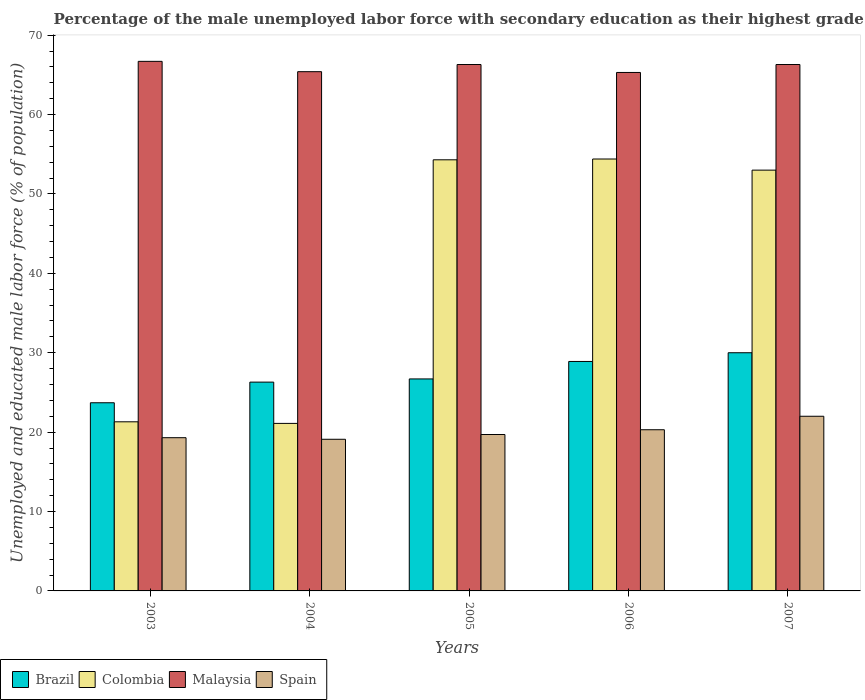How many different coloured bars are there?
Offer a terse response. 4. How many groups of bars are there?
Your answer should be very brief. 5. Are the number of bars on each tick of the X-axis equal?
Ensure brevity in your answer.  Yes. How many bars are there on the 2nd tick from the left?
Provide a succinct answer. 4. What is the percentage of the unemployed male labor force with secondary education in Colombia in 2003?
Provide a succinct answer. 21.3. Across all years, what is the maximum percentage of the unemployed male labor force with secondary education in Malaysia?
Your response must be concise. 66.7. Across all years, what is the minimum percentage of the unemployed male labor force with secondary education in Brazil?
Offer a very short reply. 23.7. In which year was the percentage of the unemployed male labor force with secondary education in Spain maximum?
Make the answer very short. 2007. What is the total percentage of the unemployed male labor force with secondary education in Spain in the graph?
Provide a succinct answer. 100.4. What is the difference between the percentage of the unemployed male labor force with secondary education in Malaysia in 2004 and that in 2005?
Your answer should be very brief. -0.9. What is the difference between the percentage of the unemployed male labor force with secondary education in Spain in 2007 and the percentage of the unemployed male labor force with secondary education in Brazil in 2006?
Give a very brief answer. -6.9. What is the average percentage of the unemployed male labor force with secondary education in Malaysia per year?
Provide a succinct answer. 66. In the year 2007, what is the difference between the percentage of the unemployed male labor force with secondary education in Spain and percentage of the unemployed male labor force with secondary education in Colombia?
Ensure brevity in your answer.  -31. What is the ratio of the percentage of the unemployed male labor force with secondary education in Brazil in 2004 to that in 2006?
Provide a succinct answer. 0.91. Is the percentage of the unemployed male labor force with secondary education in Spain in 2003 less than that in 2006?
Keep it short and to the point. Yes. Is the difference between the percentage of the unemployed male labor force with secondary education in Spain in 2003 and 2006 greater than the difference between the percentage of the unemployed male labor force with secondary education in Colombia in 2003 and 2006?
Provide a succinct answer. Yes. What is the difference between the highest and the second highest percentage of the unemployed male labor force with secondary education in Colombia?
Your response must be concise. 0.1. What is the difference between the highest and the lowest percentage of the unemployed male labor force with secondary education in Spain?
Make the answer very short. 2.9. What does the 1st bar from the right in 2006 represents?
Offer a terse response. Spain. Are all the bars in the graph horizontal?
Your answer should be very brief. No. What is the difference between two consecutive major ticks on the Y-axis?
Give a very brief answer. 10. Does the graph contain grids?
Give a very brief answer. No. How are the legend labels stacked?
Give a very brief answer. Horizontal. What is the title of the graph?
Make the answer very short. Percentage of the male unemployed labor force with secondary education as their highest grade. Does "St. Vincent and the Grenadines" appear as one of the legend labels in the graph?
Offer a very short reply. No. What is the label or title of the Y-axis?
Ensure brevity in your answer.  Unemployed and educated male labor force (% of population). What is the Unemployed and educated male labor force (% of population) of Brazil in 2003?
Keep it short and to the point. 23.7. What is the Unemployed and educated male labor force (% of population) of Colombia in 2003?
Provide a succinct answer. 21.3. What is the Unemployed and educated male labor force (% of population) in Malaysia in 2003?
Your response must be concise. 66.7. What is the Unemployed and educated male labor force (% of population) of Spain in 2003?
Ensure brevity in your answer.  19.3. What is the Unemployed and educated male labor force (% of population) in Brazil in 2004?
Give a very brief answer. 26.3. What is the Unemployed and educated male labor force (% of population) of Colombia in 2004?
Your response must be concise. 21.1. What is the Unemployed and educated male labor force (% of population) of Malaysia in 2004?
Offer a terse response. 65.4. What is the Unemployed and educated male labor force (% of population) in Spain in 2004?
Keep it short and to the point. 19.1. What is the Unemployed and educated male labor force (% of population) of Brazil in 2005?
Your answer should be compact. 26.7. What is the Unemployed and educated male labor force (% of population) in Colombia in 2005?
Give a very brief answer. 54.3. What is the Unemployed and educated male labor force (% of population) of Malaysia in 2005?
Your answer should be very brief. 66.3. What is the Unemployed and educated male labor force (% of population) of Spain in 2005?
Offer a very short reply. 19.7. What is the Unemployed and educated male labor force (% of population) in Brazil in 2006?
Your response must be concise. 28.9. What is the Unemployed and educated male labor force (% of population) in Colombia in 2006?
Your answer should be compact. 54.4. What is the Unemployed and educated male labor force (% of population) of Malaysia in 2006?
Make the answer very short. 65.3. What is the Unemployed and educated male labor force (% of population) of Spain in 2006?
Provide a short and direct response. 20.3. What is the Unemployed and educated male labor force (% of population) in Brazil in 2007?
Make the answer very short. 30. What is the Unemployed and educated male labor force (% of population) of Malaysia in 2007?
Make the answer very short. 66.3. Across all years, what is the maximum Unemployed and educated male labor force (% of population) in Colombia?
Your answer should be very brief. 54.4. Across all years, what is the maximum Unemployed and educated male labor force (% of population) of Malaysia?
Your response must be concise. 66.7. Across all years, what is the minimum Unemployed and educated male labor force (% of population) of Brazil?
Provide a succinct answer. 23.7. Across all years, what is the minimum Unemployed and educated male labor force (% of population) in Colombia?
Make the answer very short. 21.1. Across all years, what is the minimum Unemployed and educated male labor force (% of population) in Malaysia?
Your response must be concise. 65.3. Across all years, what is the minimum Unemployed and educated male labor force (% of population) in Spain?
Your answer should be very brief. 19.1. What is the total Unemployed and educated male labor force (% of population) in Brazil in the graph?
Your answer should be compact. 135.6. What is the total Unemployed and educated male labor force (% of population) of Colombia in the graph?
Offer a very short reply. 204.1. What is the total Unemployed and educated male labor force (% of population) of Malaysia in the graph?
Keep it short and to the point. 330. What is the total Unemployed and educated male labor force (% of population) of Spain in the graph?
Your answer should be very brief. 100.4. What is the difference between the Unemployed and educated male labor force (% of population) of Colombia in 2003 and that in 2004?
Your answer should be compact. 0.2. What is the difference between the Unemployed and educated male labor force (% of population) of Malaysia in 2003 and that in 2004?
Your answer should be compact. 1.3. What is the difference between the Unemployed and educated male labor force (% of population) in Colombia in 2003 and that in 2005?
Make the answer very short. -33. What is the difference between the Unemployed and educated male labor force (% of population) in Brazil in 2003 and that in 2006?
Your answer should be very brief. -5.2. What is the difference between the Unemployed and educated male labor force (% of population) in Colombia in 2003 and that in 2006?
Keep it short and to the point. -33.1. What is the difference between the Unemployed and educated male labor force (% of population) in Malaysia in 2003 and that in 2006?
Your answer should be very brief. 1.4. What is the difference between the Unemployed and educated male labor force (% of population) of Brazil in 2003 and that in 2007?
Ensure brevity in your answer.  -6.3. What is the difference between the Unemployed and educated male labor force (% of population) in Colombia in 2003 and that in 2007?
Provide a succinct answer. -31.7. What is the difference between the Unemployed and educated male labor force (% of population) of Malaysia in 2003 and that in 2007?
Your answer should be very brief. 0.4. What is the difference between the Unemployed and educated male labor force (% of population) of Brazil in 2004 and that in 2005?
Your answer should be very brief. -0.4. What is the difference between the Unemployed and educated male labor force (% of population) in Colombia in 2004 and that in 2005?
Your answer should be compact. -33.2. What is the difference between the Unemployed and educated male labor force (% of population) in Malaysia in 2004 and that in 2005?
Keep it short and to the point. -0.9. What is the difference between the Unemployed and educated male labor force (% of population) of Spain in 2004 and that in 2005?
Provide a short and direct response. -0.6. What is the difference between the Unemployed and educated male labor force (% of population) in Brazil in 2004 and that in 2006?
Your response must be concise. -2.6. What is the difference between the Unemployed and educated male labor force (% of population) of Colombia in 2004 and that in 2006?
Provide a succinct answer. -33.3. What is the difference between the Unemployed and educated male labor force (% of population) in Colombia in 2004 and that in 2007?
Your answer should be compact. -31.9. What is the difference between the Unemployed and educated male labor force (% of population) of Spain in 2004 and that in 2007?
Provide a short and direct response. -2.9. What is the difference between the Unemployed and educated male labor force (% of population) of Brazil in 2005 and that in 2006?
Your answer should be compact. -2.2. What is the difference between the Unemployed and educated male labor force (% of population) of Colombia in 2005 and that in 2006?
Give a very brief answer. -0.1. What is the difference between the Unemployed and educated male labor force (% of population) of Spain in 2005 and that in 2006?
Your answer should be compact. -0.6. What is the difference between the Unemployed and educated male labor force (% of population) of Spain in 2005 and that in 2007?
Keep it short and to the point. -2.3. What is the difference between the Unemployed and educated male labor force (% of population) in Colombia in 2006 and that in 2007?
Your response must be concise. 1.4. What is the difference between the Unemployed and educated male labor force (% of population) of Malaysia in 2006 and that in 2007?
Offer a terse response. -1. What is the difference between the Unemployed and educated male labor force (% of population) of Spain in 2006 and that in 2007?
Your answer should be compact. -1.7. What is the difference between the Unemployed and educated male labor force (% of population) in Brazil in 2003 and the Unemployed and educated male labor force (% of population) in Malaysia in 2004?
Provide a short and direct response. -41.7. What is the difference between the Unemployed and educated male labor force (% of population) in Colombia in 2003 and the Unemployed and educated male labor force (% of population) in Malaysia in 2004?
Your answer should be compact. -44.1. What is the difference between the Unemployed and educated male labor force (% of population) in Malaysia in 2003 and the Unemployed and educated male labor force (% of population) in Spain in 2004?
Keep it short and to the point. 47.6. What is the difference between the Unemployed and educated male labor force (% of population) of Brazil in 2003 and the Unemployed and educated male labor force (% of population) of Colombia in 2005?
Your response must be concise. -30.6. What is the difference between the Unemployed and educated male labor force (% of population) in Brazil in 2003 and the Unemployed and educated male labor force (% of population) in Malaysia in 2005?
Your response must be concise. -42.6. What is the difference between the Unemployed and educated male labor force (% of population) in Colombia in 2003 and the Unemployed and educated male labor force (% of population) in Malaysia in 2005?
Offer a very short reply. -45. What is the difference between the Unemployed and educated male labor force (% of population) of Colombia in 2003 and the Unemployed and educated male labor force (% of population) of Spain in 2005?
Your answer should be very brief. 1.6. What is the difference between the Unemployed and educated male labor force (% of population) of Malaysia in 2003 and the Unemployed and educated male labor force (% of population) of Spain in 2005?
Offer a terse response. 47. What is the difference between the Unemployed and educated male labor force (% of population) in Brazil in 2003 and the Unemployed and educated male labor force (% of population) in Colombia in 2006?
Make the answer very short. -30.7. What is the difference between the Unemployed and educated male labor force (% of population) in Brazil in 2003 and the Unemployed and educated male labor force (% of population) in Malaysia in 2006?
Offer a terse response. -41.6. What is the difference between the Unemployed and educated male labor force (% of population) of Brazil in 2003 and the Unemployed and educated male labor force (% of population) of Spain in 2006?
Provide a succinct answer. 3.4. What is the difference between the Unemployed and educated male labor force (% of population) in Colombia in 2003 and the Unemployed and educated male labor force (% of population) in Malaysia in 2006?
Offer a very short reply. -44. What is the difference between the Unemployed and educated male labor force (% of population) of Malaysia in 2003 and the Unemployed and educated male labor force (% of population) of Spain in 2006?
Ensure brevity in your answer.  46.4. What is the difference between the Unemployed and educated male labor force (% of population) in Brazil in 2003 and the Unemployed and educated male labor force (% of population) in Colombia in 2007?
Give a very brief answer. -29.3. What is the difference between the Unemployed and educated male labor force (% of population) of Brazil in 2003 and the Unemployed and educated male labor force (% of population) of Malaysia in 2007?
Give a very brief answer. -42.6. What is the difference between the Unemployed and educated male labor force (% of population) of Brazil in 2003 and the Unemployed and educated male labor force (% of population) of Spain in 2007?
Offer a terse response. 1.7. What is the difference between the Unemployed and educated male labor force (% of population) in Colombia in 2003 and the Unemployed and educated male labor force (% of population) in Malaysia in 2007?
Give a very brief answer. -45. What is the difference between the Unemployed and educated male labor force (% of population) of Colombia in 2003 and the Unemployed and educated male labor force (% of population) of Spain in 2007?
Your answer should be compact. -0.7. What is the difference between the Unemployed and educated male labor force (% of population) in Malaysia in 2003 and the Unemployed and educated male labor force (% of population) in Spain in 2007?
Your response must be concise. 44.7. What is the difference between the Unemployed and educated male labor force (% of population) in Brazil in 2004 and the Unemployed and educated male labor force (% of population) in Colombia in 2005?
Make the answer very short. -28. What is the difference between the Unemployed and educated male labor force (% of population) of Brazil in 2004 and the Unemployed and educated male labor force (% of population) of Malaysia in 2005?
Provide a short and direct response. -40. What is the difference between the Unemployed and educated male labor force (% of population) of Colombia in 2004 and the Unemployed and educated male labor force (% of population) of Malaysia in 2005?
Offer a terse response. -45.2. What is the difference between the Unemployed and educated male labor force (% of population) of Malaysia in 2004 and the Unemployed and educated male labor force (% of population) of Spain in 2005?
Provide a succinct answer. 45.7. What is the difference between the Unemployed and educated male labor force (% of population) of Brazil in 2004 and the Unemployed and educated male labor force (% of population) of Colombia in 2006?
Your answer should be compact. -28.1. What is the difference between the Unemployed and educated male labor force (% of population) in Brazil in 2004 and the Unemployed and educated male labor force (% of population) in Malaysia in 2006?
Offer a terse response. -39. What is the difference between the Unemployed and educated male labor force (% of population) in Brazil in 2004 and the Unemployed and educated male labor force (% of population) in Spain in 2006?
Provide a succinct answer. 6. What is the difference between the Unemployed and educated male labor force (% of population) in Colombia in 2004 and the Unemployed and educated male labor force (% of population) in Malaysia in 2006?
Offer a very short reply. -44.2. What is the difference between the Unemployed and educated male labor force (% of population) of Colombia in 2004 and the Unemployed and educated male labor force (% of population) of Spain in 2006?
Provide a succinct answer. 0.8. What is the difference between the Unemployed and educated male labor force (% of population) of Malaysia in 2004 and the Unemployed and educated male labor force (% of population) of Spain in 2006?
Make the answer very short. 45.1. What is the difference between the Unemployed and educated male labor force (% of population) of Brazil in 2004 and the Unemployed and educated male labor force (% of population) of Colombia in 2007?
Keep it short and to the point. -26.7. What is the difference between the Unemployed and educated male labor force (% of population) of Brazil in 2004 and the Unemployed and educated male labor force (% of population) of Malaysia in 2007?
Your answer should be very brief. -40. What is the difference between the Unemployed and educated male labor force (% of population) of Colombia in 2004 and the Unemployed and educated male labor force (% of population) of Malaysia in 2007?
Make the answer very short. -45.2. What is the difference between the Unemployed and educated male labor force (% of population) of Colombia in 2004 and the Unemployed and educated male labor force (% of population) of Spain in 2007?
Provide a short and direct response. -0.9. What is the difference between the Unemployed and educated male labor force (% of population) in Malaysia in 2004 and the Unemployed and educated male labor force (% of population) in Spain in 2007?
Keep it short and to the point. 43.4. What is the difference between the Unemployed and educated male labor force (% of population) in Brazil in 2005 and the Unemployed and educated male labor force (% of population) in Colombia in 2006?
Make the answer very short. -27.7. What is the difference between the Unemployed and educated male labor force (% of population) in Brazil in 2005 and the Unemployed and educated male labor force (% of population) in Malaysia in 2006?
Offer a terse response. -38.6. What is the difference between the Unemployed and educated male labor force (% of population) of Colombia in 2005 and the Unemployed and educated male labor force (% of population) of Malaysia in 2006?
Give a very brief answer. -11. What is the difference between the Unemployed and educated male labor force (% of population) in Colombia in 2005 and the Unemployed and educated male labor force (% of population) in Spain in 2006?
Make the answer very short. 34. What is the difference between the Unemployed and educated male labor force (% of population) of Brazil in 2005 and the Unemployed and educated male labor force (% of population) of Colombia in 2007?
Your answer should be compact. -26.3. What is the difference between the Unemployed and educated male labor force (% of population) of Brazil in 2005 and the Unemployed and educated male labor force (% of population) of Malaysia in 2007?
Your answer should be compact. -39.6. What is the difference between the Unemployed and educated male labor force (% of population) in Brazil in 2005 and the Unemployed and educated male labor force (% of population) in Spain in 2007?
Ensure brevity in your answer.  4.7. What is the difference between the Unemployed and educated male labor force (% of population) in Colombia in 2005 and the Unemployed and educated male labor force (% of population) in Malaysia in 2007?
Give a very brief answer. -12. What is the difference between the Unemployed and educated male labor force (% of population) in Colombia in 2005 and the Unemployed and educated male labor force (% of population) in Spain in 2007?
Give a very brief answer. 32.3. What is the difference between the Unemployed and educated male labor force (% of population) in Malaysia in 2005 and the Unemployed and educated male labor force (% of population) in Spain in 2007?
Your answer should be very brief. 44.3. What is the difference between the Unemployed and educated male labor force (% of population) in Brazil in 2006 and the Unemployed and educated male labor force (% of population) in Colombia in 2007?
Your answer should be compact. -24.1. What is the difference between the Unemployed and educated male labor force (% of population) in Brazil in 2006 and the Unemployed and educated male labor force (% of population) in Malaysia in 2007?
Provide a short and direct response. -37.4. What is the difference between the Unemployed and educated male labor force (% of population) in Colombia in 2006 and the Unemployed and educated male labor force (% of population) in Spain in 2007?
Ensure brevity in your answer.  32.4. What is the difference between the Unemployed and educated male labor force (% of population) of Malaysia in 2006 and the Unemployed and educated male labor force (% of population) of Spain in 2007?
Provide a short and direct response. 43.3. What is the average Unemployed and educated male labor force (% of population) in Brazil per year?
Offer a very short reply. 27.12. What is the average Unemployed and educated male labor force (% of population) of Colombia per year?
Give a very brief answer. 40.82. What is the average Unemployed and educated male labor force (% of population) of Malaysia per year?
Your answer should be compact. 66. What is the average Unemployed and educated male labor force (% of population) of Spain per year?
Provide a short and direct response. 20.08. In the year 2003, what is the difference between the Unemployed and educated male labor force (% of population) of Brazil and Unemployed and educated male labor force (% of population) of Malaysia?
Ensure brevity in your answer.  -43. In the year 2003, what is the difference between the Unemployed and educated male labor force (% of population) in Brazil and Unemployed and educated male labor force (% of population) in Spain?
Your answer should be very brief. 4.4. In the year 2003, what is the difference between the Unemployed and educated male labor force (% of population) in Colombia and Unemployed and educated male labor force (% of population) in Malaysia?
Your answer should be very brief. -45.4. In the year 2003, what is the difference between the Unemployed and educated male labor force (% of population) in Malaysia and Unemployed and educated male labor force (% of population) in Spain?
Ensure brevity in your answer.  47.4. In the year 2004, what is the difference between the Unemployed and educated male labor force (% of population) in Brazil and Unemployed and educated male labor force (% of population) in Malaysia?
Give a very brief answer. -39.1. In the year 2004, what is the difference between the Unemployed and educated male labor force (% of population) in Brazil and Unemployed and educated male labor force (% of population) in Spain?
Offer a very short reply. 7.2. In the year 2004, what is the difference between the Unemployed and educated male labor force (% of population) in Colombia and Unemployed and educated male labor force (% of population) in Malaysia?
Your response must be concise. -44.3. In the year 2004, what is the difference between the Unemployed and educated male labor force (% of population) in Malaysia and Unemployed and educated male labor force (% of population) in Spain?
Provide a succinct answer. 46.3. In the year 2005, what is the difference between the Unemployed and educated male labor force (% of population) of Brazil and Unemployed and educated male labor force (% of population) of Colombia?
Provide a succinct answer. -27.6. In the year 2005, what is the difference between the Unemployed and educated male labor force (% of population) in Brazil and Unemployed and educated male labor force (% of population) in Malaysia?
Your response must be concise. -39.6. In the year 2005, what is the difference between the Unemployed and educated male labor force (% of population) in Colombia and Unemployed and educated male labor force (% of population) in Spain?
Your response must be concise. 34.6. In the year 2005, what is the difference between the Unemployed and educated male labor force (% of population) in Malaysia and Unemployed and educated male labor force (% of population) in Spain?
Keep it short and to the point. 46.6. In the year 2006, what is the difference between the Unemployed and educated male labor force (% of population) in Brazil and Unemployed and educated male labor force (% of population) in Colombia?
Keep it short and to the point. -25.5. In the year 2006, what is the difference between the Unemployed and educated male labor force (% of population) of Brazil and Unemployed and educated male labor force (% of population) of Malaysia?
Your response must be concise. -36.4. In the year 2006, what is the difference between the Unemployed and educated male labor force (% of population) in Brazil and Unemployed and educated male labor force (% of population) in Spain?
Your answer should be very brief. 8.6. In the year 2006, what is the difference between the Unemployed and educated male labor force (% of population) of Colombia and Unemployed and educated male labor force (% of population) of Spain?
Keep it short and to the point. 34.1. In the year 2006, what is the difference between the Unemployed and educated male labor force (% of population) in Malaysia and Unemployed and educated male labor force (% of population) in Spain?
Offer a terse response. 45. In the year 2007, what is the difference between the Unemployed and educated male labor force (% of population) of Brazil and Unemployed and educated male labor force (% of population) of Malaysia?
Provide a short and direct response. -36.3. In the year 2007, what is the difference between the Unemployed and educated male labor force (% of population) in Brazil and Unemployed and educated male labor force (% of population) in Spain?
Ensure brevity in your answer.  8. In the year 2007, what is the difference between the Unemployed and educated male labor force (% of population) in Malaysia and Unemployed and educated male labor force (% of population) in Spain?
Keep it short and to the point. 44.3. What is the ratio of the Unemployed and educated male labor force (% of population) of Brazil in 2003 to that in 2004?
Give a very brief answer. 0.9. What is the ratio of the Unemployed and educated male labor force (% of population) in Colombia in 2003 to that in 2004?
Give a very brief answer. 1.01. What is the ratio of the Unemployed and educated male labor force (% of population) in Malaysia in 2003 to that in 2004?
Your response must be concise. 1.02. What is the ratio of the Unemployed and educated male labor force (% of population) of Spain in 2003 to that in 2004?
Offer a very short reply. 1.01. What is the ratio of the Unemployed and educated male labor force (% of population) of Brazil in 2003 to that in 2005?
Offer a very short reply. 0.89. What is the ratio of the Unemployed and educated male labor force (% of population) in Colombia in 2003 to that in 2005?
Provide a succinct answer. 0.39. What is the ratio of the Unemployed and educated male labor force (% of population) of Spain in 2003 to that in 2005?
Your answer should be very brief. 0.98. What is the ratio of the Unemployed and educated male labor force (% of population) of Brazil in 2003 to that in 2006?
Your answer should be compact. 0.82. What is the ratio of the Unemployed and educated male labor force (% of population) in Colombia in 2003 to that in 2006?
Offer a very short reply. 0.39. What is the ratio of the Unemployed and educated male labor force (% of population) of Malaysia in 2003 to that in 2006?
Keep it short and to the point. 1.02. What is the ratio of the Unemployed and educated male labor force (% of population) of Spain in 2003 to that in 2006?
Give a very brief answer. 0.95. What is the ratio of the Unemployed and educated male labor force (% of population) of Brazil in 2003 to that in 2007?
Offer a very short reply. 0.79. What is the ratio of the Unemployed and educated male labor force (% of population) of Colombia in 2003 to that in 2007?
Your answer should be very brief. 0.4. What is the ratio of the Unemployed and educated male labor force (% of population) in Spain in 2003 to that in 2007?
Provide a short and direct response. 0.88. What is the ratio of the Unemployed and educated male labor force (% of population) of Colombia in 2004 to that in 2005?
Keep it short and to the point. 0.39. What is the ratio of the Unemployed and educated male labor force (% of population) in Malaysia in 2004 to that in 2005?
Your answer should be very brief. 0.99. What is the ratio of the Unemployed and educated male labor force (% of population) of Spain in 2004 to that in 2005?
Provide a short and direct response. 0.97. What is the ratio of the Unemployed and educated male labor force (% of population) of Brazil in 2004 to that in 2006?
Ensure brevity in your answer.  0.91. What is the ratio of the Unemployed and educated male labor force (% of population) in Colombia in 2004 to that in 2006?
Offer a very short reply. 0.39. What is the ratio of the Unemployed and educated male labor force (% of population) in Spain in 2004 to that in 2006?
Your answer should be compact. 0.94. What is the ratio of the Unemployed and educated male labor force (% of population) of Brazil in 2004 to that in 2007?
Offer a terse response. 0.88. What is the ratio of the Unemployed and educated male labor force (% of population) of Colombia in 2004 to that in 2007?
Your response must be concise. 0.4. What is the ratio of the Unemployed and educated male labor force (% of population) in Malaysia in 2004 to that in 2007?
Make the answer very short. 0.99. What is the ratio of the Unemployed and educated male labor force (% of population) of Spain in 2004 to that in 2007?
Keep it short and to the point. 0.87. What is the ratio of the Unemployed and educated male labor force (% of population) of Brazil in 2005 to that in 2006?
Your answer should be very brief. 0.92. What is the ratio of the Unemployed and educated male labor force (% of population) of Malaysia in 2005 to that in 2006?
Give a very brief answer. 1.02. What is the ratio of the Unemployed and educated male labor force (% of population) of Spain in 2005 to that in 2006?
Your answer should be very brief. 0.97. What is the ratio of the Unemployed and educated male labor force (% of population) in Brazil in 2005 to that in 2007?
Give a very brief answer. 0.89. What is the ratio of the Unemployed and educated male labor force (% of population) of Colombia in 2005 to that in 2007?
Give a very brief answer. 1.02. What is the ratio of the Unemployed and educated male labor force (% of population) in Malaysia in 2005 to that in 2007?
Give a very brief answer. 1. What is the ratio of the Unemployed and educated male labor force (% of population) in Spain in 2005 to that in 2007?
Offer a very short reply. 0.9. What is the ratio of the Unemployed and educated male labor force (% of population) of Brazil in 2006 to that in 2007?
Offer a terse response. 0.96. What is the ratio of the Unemployed and educated male labor force (% of population) of Colombia in 2006 to that in 2007?
Make the answer very short. 1.03. What is the ratio of the Unemployed and educated male labor force (% of population) of Malaysia in 2006 to that in 2007?
Offer a very short reply. 0.98. What is the ratio of the Unemployed and educated male labor force (% of population) of Spain in 2006 to that in 2007?
Provide a succinct answer. 0.92. What is the difference between the highest and the second highest Unemployed and educated male labor force (% of population) of Colombia?
Offer a terse response. 0.1. What is the difference between the highest and the second highest Unemployed and educated male labor force (% of population) of Malaysia?
Provide a succinct answer. 0.4. What is the difference between the highest and the second highest Unemployed and educated male labor force (% of population) of Spain?
Offer a terse response. 1.7. What is the difference between the highest and the lowest Unemployed and educated male labor force (% of population) of Brazil?
Make the answer very short. 6.3. What is the difference between the highest and the lowest Unemployed and educated male labor force (% of population) of Colombia?
Give a very brief answer. 33.3. What is the difference between the highest and the lowest Unemployed and educated male labor force (% of population) of Malaysia?
Your answer should be compact. 1.4. What is the difference between the highest and the lowest Unemployed and educated male labor force (% of population) of Spain?
Ensure brevity in your answer.  2.9. 